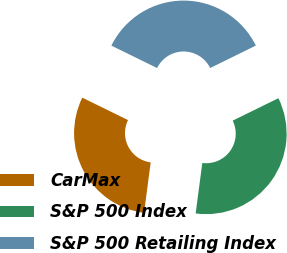<chart> <loc_0><loc_0><loc_500><loc_500><pie_chart><fcel>CarMax<fcel>S&P 500 Index<fcel>S&P 500 Retailing Index<nl><fcel>30.17%<fcel>34.35%<fcel>35.48%<nl></chart> 